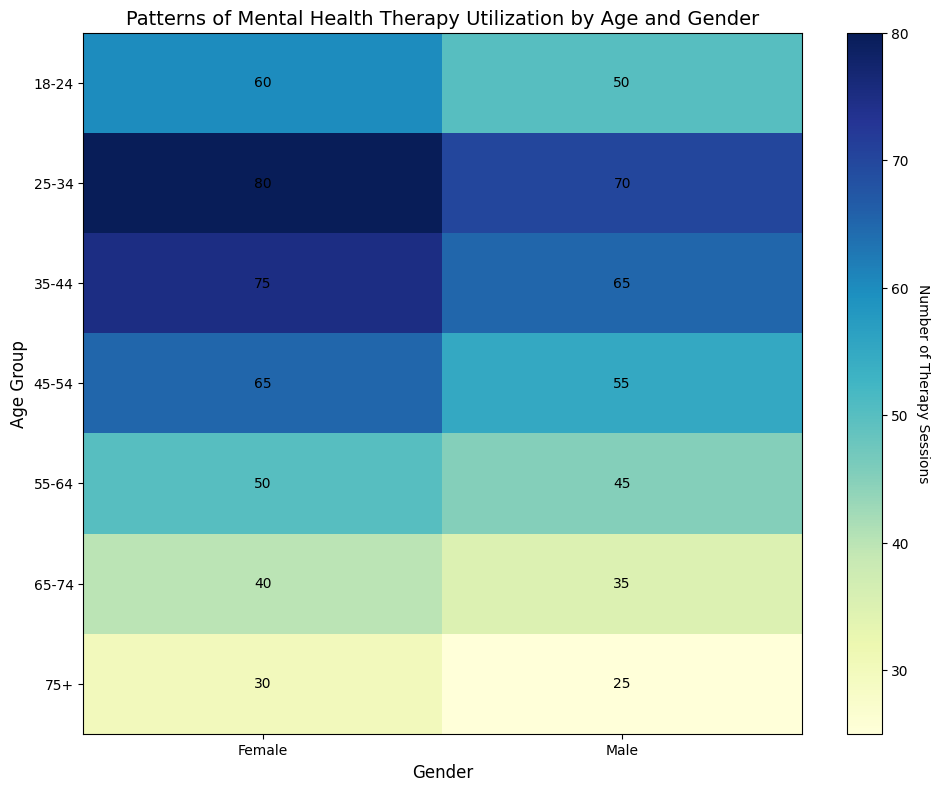Which age group and gender combination has the highest number of therapy sessions? To determine this, we look for the brightest-colored cell. The brightest cell corresponds to the "25-34" age group for "Female," with 80 therapy sessions.
Answer: 25-34 Female Which age group and gender combination has the lowest number of therapy sessions? To find this, we look for the darkest-colored cell. The darkest cell corresponds to the "75+" age group for "Male," with 25 therapy sessions.
Answer: 75+ Male How many more therapy sessions do females aged 25-34 have compared to males aged 25-34? The number of therapy sessions for females aged 25-34 is 80, and for males of the same age group, it’s 70. Subtract 70 from 80 to get the difference. 80 - 70 = 10.
Answer: 10 What is the total number of therapy sessions for the age group 45-54? Sum the values for both males and females in this age group. 55 (Male) + 65 (Female) = 120.
Answer: 120 Compare the number of therapy sessions for males aged 35-44 and females aged 55-64. Which group has more and by how much? Males aged 35-44 have 65 sessions, while females aged 55-64 have 50 sessions. 65 - 50 = 15, so males aged 35-44 have 15 more sessions.
Answer: Males aged 35-44 by 15 What is the average number of therapy sessions for females across all age groups? Sum the number of therapy sessions for all female age groups and divide by the number of age groups. (60 + 80 + 75 + 65 + 50 + 40 + 30) / 7 = 400 / 7 ≈ 57.14.
Answer: ≈ 57.14 How does the utilization of therapy sessions change with age for males? Observing the heatmap for males from youngest to oldest, we see the image darken, indicating a decrease: 50 (18-24), 70 (25-34), 65 (35-44), 55 (45-54), 45 (55-64), 35 (65-74), and 25 (75+). It generally decreases as age increases.
Answer: Decreases with age What is the ratio of therapy sessions between females aged 18-24 and males aged 65-74? The number of sessions for females aged 18-24 is 60, and for males aged 65-74 it is 35. The ratio is 60:35, which simplifies to 12:7.
Answer: 12:7 Which gender utilizes therapy sessions more frequently in the age group 55-64? Compare the numbers in the heatmap for the 55-64 age group: 45 for males and 50 for females. Females have a higher count.
Answer: Female 